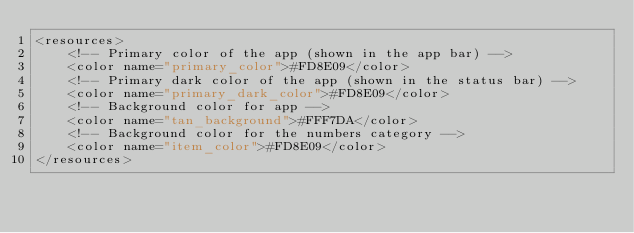<code> <loc_0><loc_0><loc_500><loc_500><_XML_><resources>
    <!-- Primary color of the app (shown in the app bar) -->
    <color name="primary_color">#FD8E09</color>
    <!-- Primary dark color of the app (shown in the status bar) -->
    <color name="primary_dark_color">#FD8E09</color>
    <!-- Background color for app -->
    <color name="tan_background">#FFF7DA</color>
    <!-- Background color for the numbers category -->
    <color name="item_color">#FD8E09</color>
</resources>
</code> 